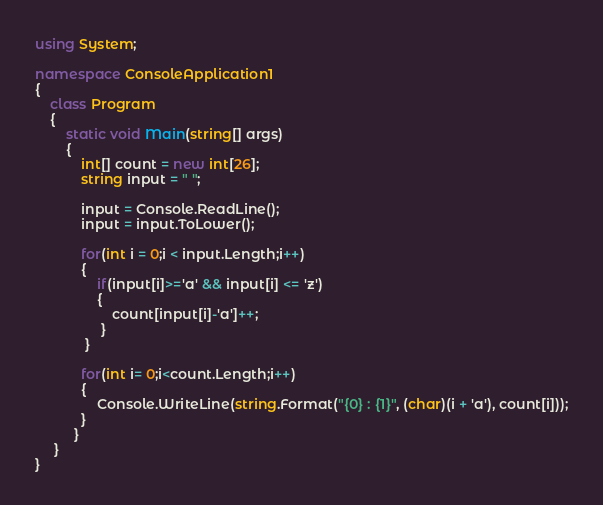Convert code to text. <code><loc_0><loc_0><loc_500><loc_500><_C#_>using System;

namespace ConsoleApplication1
{
    class Program
    {
        static void Main(string[] args)
        {
            int[] count = new int[26];
            string input = " ";

            input = Console.ReadLine();
            input = input.ToLower();

            for(int i = 0;i < input.Length;i++)
            {
                if(input[i]>='a' && input[i] <= 'z')
                {
                    count[input[i]-'a']++;
                 }
             }

            for(int i= 0;i<count.Length;i++)
            {
                Console.WriteLine(string.Format("{0} : {1}", (char)(i + 'a'), count[i]));
            }
          }
     }
}</code> 